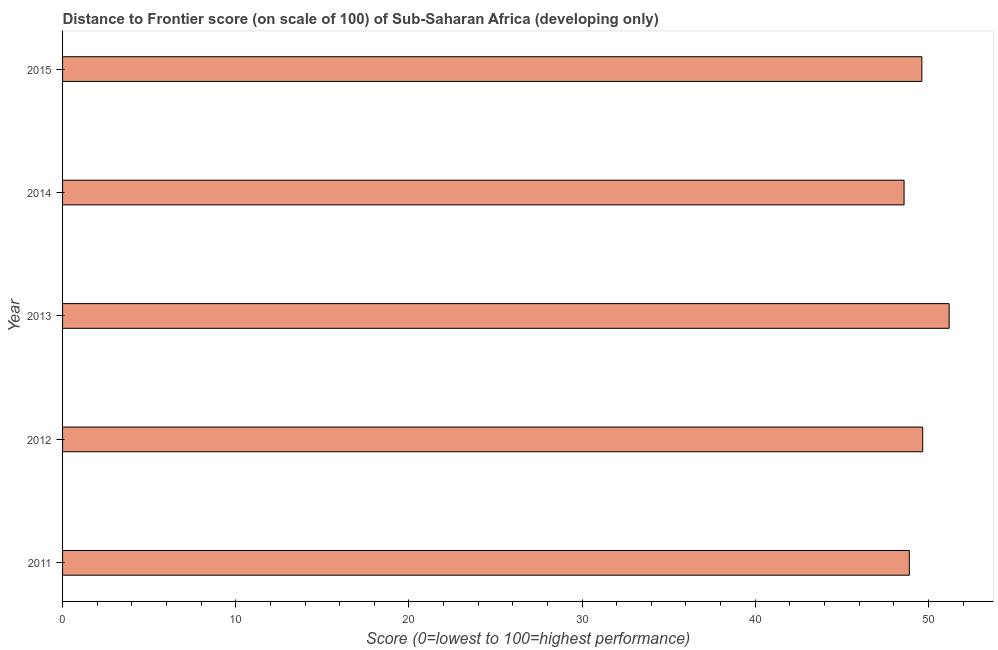Does the graph contain grids?
Provide a succinct answer. No. What is the title of the graph?
Your answer should be compact. Distance to Frontier score (on scale of 100) of Sub-Saharan Africa (developing only). What is the label or title of the X-axis?
Your answer should be compact. Score (0=lowest to 100=highest performance). What is the distance to frontier score in 2011?
Provide a succinct answer. 48.9. Across all years, what is the maximum distance to frontier score?
Ensure brevity in your answer.  51.2. Across all years, what is the minimum distance to frontier score?
Provide a succinct answer. 48.6. In which year was the distance to frontier score minimum?
Your answer should be compact. 2014. What is the sum of the distance to frontier score?
Give a very brief answer. 247.99. What is the difference between the distance to frontier score in 2013 and 2014?
Give a very brief answer. 2.6. What is the average distance to frontier score per year?
Keep it short and to the point. 49.6. What is the median distance to frontier score?
Offer a terse response. 49.62. Do a majority of the years between 2011 and 2013 (inclusive) have distance to frontier score greater than 38 ?
Ensure brevity in your answer.  Yes. What is the ratio of the distance to frontier score in 2012 to that in 2015?
Provide a short and direct response. 1. What is the difference between the highest and the second highest distance to frontier score?
Provide a succinct answer. 1.53. In how many years, is the distance to frontier score greater than the average distance to frontier score taken over all years?
Give a very brief answer. 3. How many bars are there?
Give a very brief answer. 5. Are all the bars in the graph horizontal?
Keep it short and to the point. Yes. How many years are there in the graph?
Give a very brief answer. 5. What is the Score (0=lowest to 100=highest performance) in 2011?
Ensure brevity in your answer.  48.9. What is the Score (0=lowest to 100=highest performance) in 2012?
Ensure brevity in your answer.  49.67. What is the Score (0=lowest to 100=highest performance) in 2013?
Ensure brevity in your answer.  51.2. What is the Score (0=lowest to 100=highest performance) in 2014?
Provide a succinct answer. 48.6. What is the Score (0=lowest to 100=highest performance) in 2015?
Your answer should be compact. 49.62. What is the difference between the Score (0=lowest to 100=highest performance) in 2011 and 2012?
Provide a succinct answer. -0.77. What is the difference between the Score (0=lowest to 100=highest performance) in 2011 and 2013?
Ensure brevity in your answer.  -2.3. What is the difference between the Score (0=lowest to 100=highest performance) in 2011 and 2014?
Offer a terse response. 0.3. What is the difference between the Score (0=lowest to 100=highest performance) in 2011 and 2015?
Your response must be concise. -0.72. What is the difference between the Score (0=lowest to 100=highest performance) in 2012 and 2013?
Your response must be concise. -1.53. What is the difference between the Score (0=lowest to 100=highest performance) in 2012 and 2014?
Ensure brevity in your answer.  1.08. What is the difference between the Score (0=lowest to 100=highest performance) in 2012 and 2015?
Offer a terse response. 0.05. What is the difference between the Score (0=lowest to 100=highest performance) in 2013 and 2014?
Offer a terse response. 2.6. What is the difference between the Score (0=lowest to 100=highest performance) in 2013 and 2015?
Make the answer very short. 1.58. What is the difference between the Score (0=lowest to 100=highest performance) in 2014 and 2015?
Give a very brief answer. -1.03. What is the ratio of the Score (0=lowest to 100=highest performance) in 2011 to that in 2013?
Provide a short and direct response. 0.95. What is the ratio of the Score (0=lowest to 100=highest performance) in 2011 to that in 2014?
Ensure brevity in your answer.  1.01. What is the ratio of the Score (0=lowest to 100=highest performance) in 2012 to that in 2014?
Keep it short and to the point. 1.02. What is the ratio of the Score (0=lowest to 100=highest performance) in 2012 to that in 2015?
Your response must be concise. 1. What is the ratio of the Score (0=lowest to 100=highest performance) in 2013 to that in 2014?
Give a very brief answer. 1.05. What is the ratio of the Score (0=lowest to 100=highest performance) in 2013 to that in 2015?
Keep it short and to the point. 1.03. What is the ratio of the Score (0=lowest to 100=highest performance) in 2014 to that in 2015?
Provide a short and direct response. 0.98. 